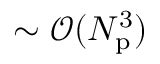<formula> <loc_0><loc_0><loc_500><loc_500>\sim \mathcal { O } ( N _ { p } ^ { 3 } )</formula> 